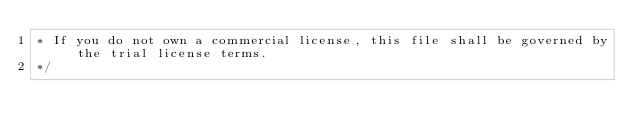Convert code to text. <code><loc_0><loc_0><loc_500><loc_500><_CSS_>* If you do not own a commercial license, this file shall be governed by the trial license terms.
*/</code> 